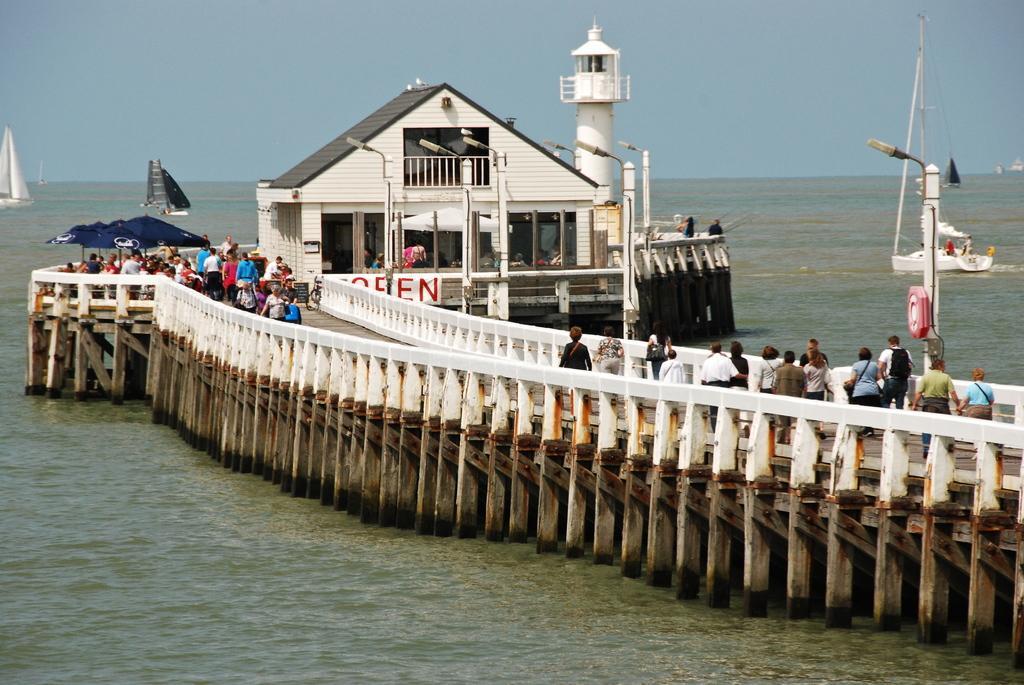Can you describe this image briefly? In the picture we can see some group of persons walking along the bridge, there is a house and in the background there are some boats which are sailing on water and top of the picture there is clear sky. 